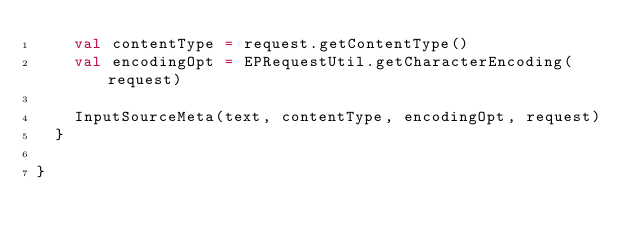Convert code to text. <code><loc_0><loc_0><loc_500><loc_500><_Scala_>    val contentType = request.getContentType()
    val encodingOpt = EPRequestUtil.getCharacterEncoding(request)

    InputSourceMeta(text, contentType, encodingOpt, request)
  }

}</code> 